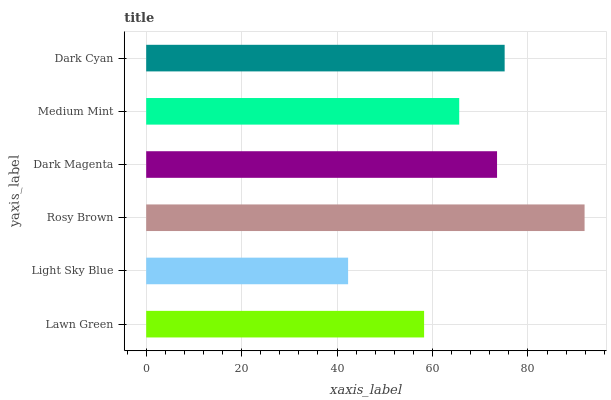Is Light Sky Blue the minimum?
Answer yes or no. Yes. Is Rosy Brown the maximum?
Answer yes or no. Yes. Is Rosy Brown the minimum?
Answer yes or no. No. Is Light Sky Blue the maximum?
Answer yes or no. No. Is Rosy Brown greater than Light Sky Blue?
Answer yes or no. Yes. Is Light Sky Blue less than Rosy Brown?
Answer yes or no. Yes. Is Light Sky Blue greater than Rosy Brown?
Answer yes or no. No. Is Rosy Brown less than Light Sky Blue?
Answer yes or no. No. Is Dark Magenta the high median?
Answer yes or no. Yes. Is Medium Mint the low median?
Answer yes or no. Yes. Is Lawn Green the high median?
Answer yes or no. No. Is Dark Cyan the low median?
Answer yes or no. No. 